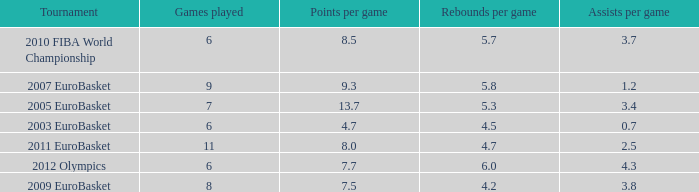How many games played have 4.7 points per game? 1.0. 